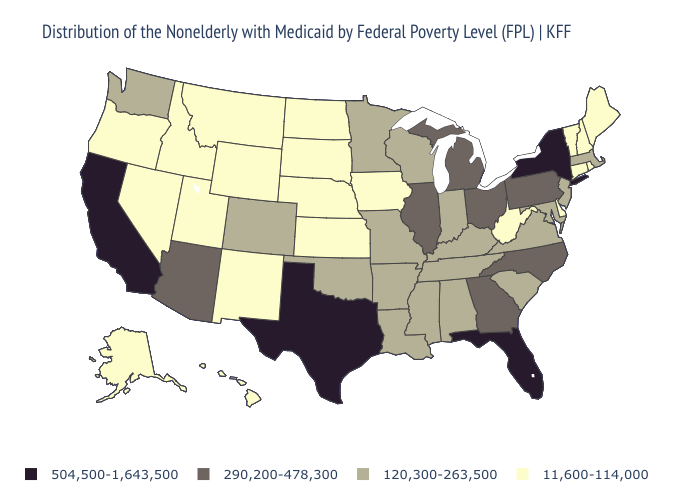Does Florida have the lowest value in the South?
Keep it brief. No. What is the lowest value in states that border Louisiana?
Keep it brief. 120,300-263,500. What is the highest value in states that border Washington?
Answer briefly. 11,600-114,000. What is the value of Virginia?
Write a very short answer. 120,300-263,500. What is the lowest value in the USA?
Concise answer only. 11,600-114,000. Name the states that have a value in the range 120,300-263,500?
Concise answer only. Alabama, Arkansas, Colorado, Indiana, Kentucky, Louisiana, Maryland, Massachusetts, Minnesota, Mississippi, Missouri, New Jersey, Oklahoma, South Carolina, Tennessee, Virginia, Washington, Wisconsin. Does Michigan have the highest value in the MidWest?
Be succinct. Yes. Name the states that have a value in the range 290,200-478,300?
Concise answer only. Arizona, Georgia, Illinois, Michigan, North Carolina, Ohio, Pennsylvania. What is the value of California?
Write a very short answer. 504,500-1,643,500. What is the value of Indiana?
Concise answer only. 120,300-263,500. Does California have the lowest value in the West?
Write a very short answer. No. Which states have the lowest value in the West?
Answer briefly. Alaska, Hawaii, Idaho, Montana, Nevada, New Mexico, Oregon, Utah, Wyoming. Name the states that have a value in the range 11,600-114,000?
Answer briefly. Alaska, Connecticut, Delaware, Hawaii, Idaho, Iowa, Kansas, Maine, Montana, Nebraska, Nevada, New Hampshire, New Mexico, North Dakota, Oregon, Rhode Island, South Dakota, Utah, Vermont, West Virginia, Wyoming. Among the states that border Massachusetts , which have the highest value?
Answer briefly. New York. 